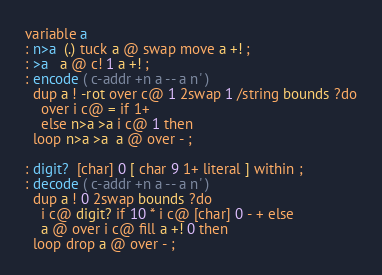<code> <loc_0><loc_0><loc_500><loc_500><_Forth_>variable a
: n>a  (.) tuck a @ swap move a +! ;
: >a   a @ c! 1 a +! ;
: encode ( c-addr +n a -- a n' )
  dup a ! -rot over c@ 1 2swap 1 /string bounds ?do
    over i c@ = if 1+
    else n>a >a i c@ 1 then
  loop n>a >a  a @ over - ;

: digit?  [char] 0 [ char 9 1+ literal ] within ;
: decode ( c-addr +n a -- a n' )
  dup a ! 0 2swap bounds ?do
    i c@ digit? if 10 * i c@ [char] 0 - + else
    a @ over i c@ fill a +! 0 then
  loop drop a @ over - ;
</code> 